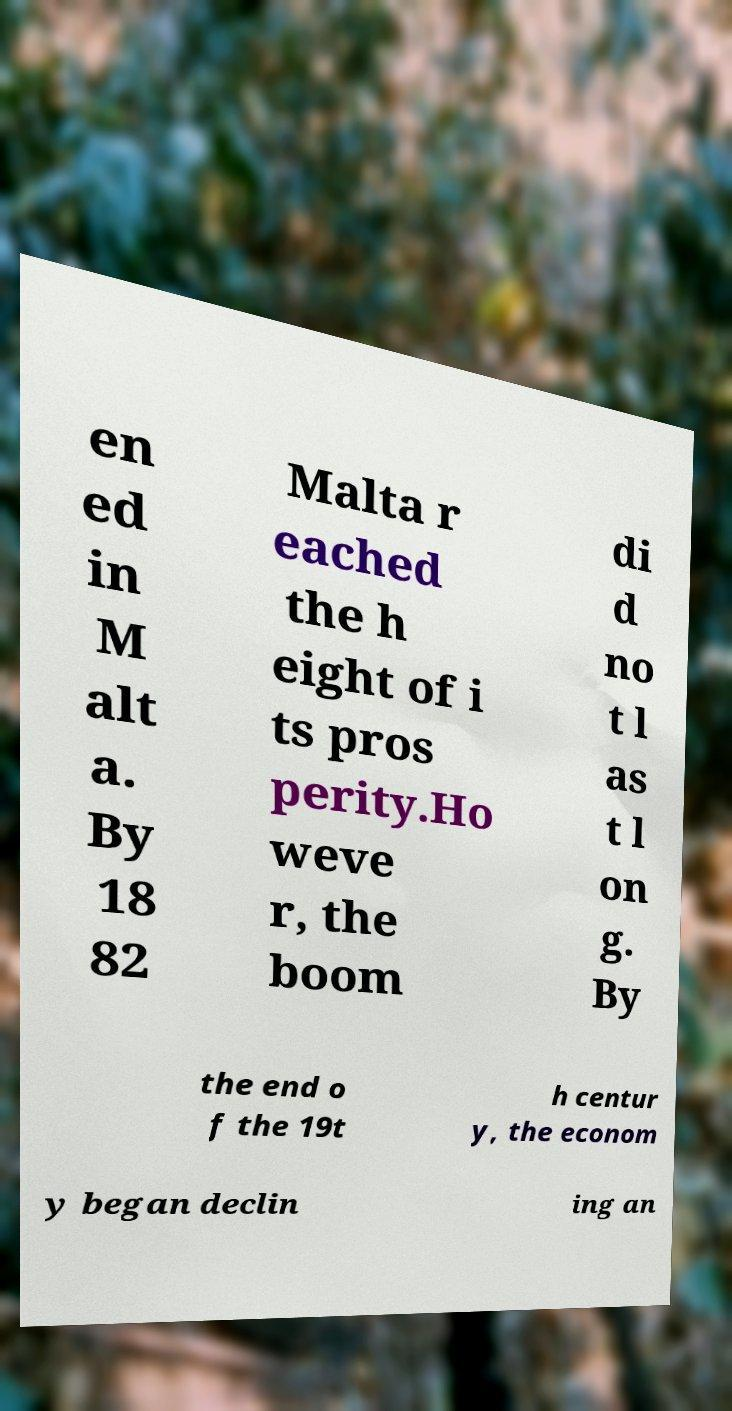Could you extract and type out the text from this image? en ed in M alt a. By 18 82 Malta r eached the h eight of i ts pros perity.Ho weve r, the boom di d no t l as t l on g. By the end o f the 19t h centur y, the econom y began declin ing an 